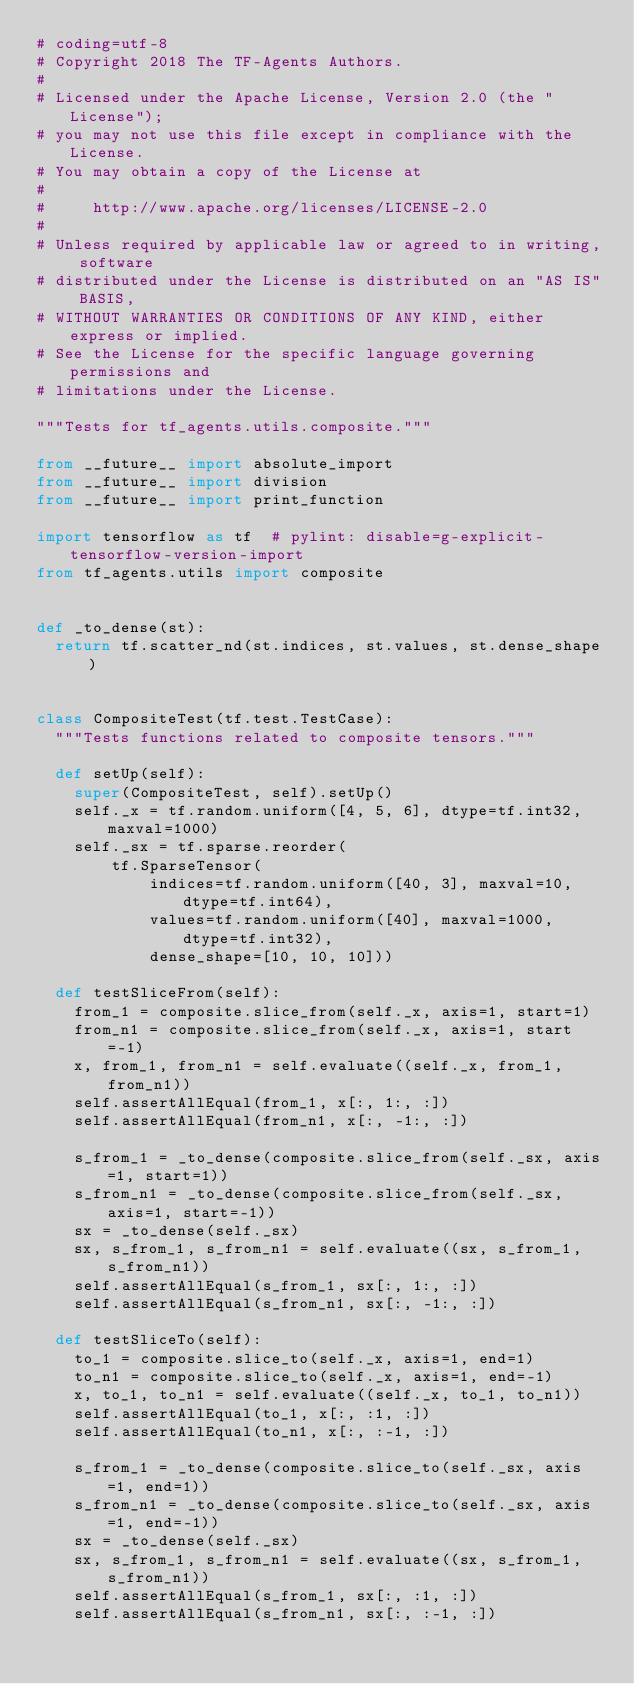<code> <loc_0><loc_0><loc_500><loc_500><_Python_># coding=utf-8
# Copyright 2018 The TF-Agents Authors.
#
# Licensed under the Apache License, Version 2.0 (the "License");
# you may not use this file except in compliance with the License.
# You may obtain a copy of the License at
#
#     http://www.apache.org/licenses/LICENSE-2.0
#
# Unless required by applicable law or agreed to in writing, software
# distributed under the License is distributed on an "AS IS" BASIS,
# WITHOUT WARRANTIES OR CONDITIONS OF ANY KIND, either express or implied.
# See the License for the specific language governing permissions and
# limitations under the License.

"""Tests for tf_agents.utils.composite."""

from __future__ import absolute_import
from __future__ import division
from __future__ import print_function

import tensorflow as tf  # pylint: disable=g-explicit-tensorflow-version-import
from tf_agents.utils import composite


def _to_dense(st):
  return tf.scatter_nd(st.indices, st.values, st.dense_shape)


class CompositeTest(tf.test.TestCase):
  """Tests functions related to composite tensors."""

  def setUp(self):
    super(CompositeTest, self).setUp()
    self._x = tf.random.uniform([4, 5, 6], dtype=tf.int32, maxval=1000)
    self._sx = tf.sparse.reorder(
        tf.SparseTensor(
            indices=tf.random.uniform([40, 3], maxval=10, dtype=tf.int64),
            values=tf.random.uniform([40], maxval=1000, dtype=tf.int32),
            dense_shape=[10, 10, 10]))

  def testSliceFrom(self):
    from_1 = composite.slice_from(self._x, axis=1, start=1)
    from_n1 = composite.slice_from(self._x, axis=1, start=-1)
    x, from_1, from_n1 = self.evaluate((self._x, from_1, from_n1))
    self.assertAllEqual(from_1, x[:, 1:, :])
    self.assertAllEqual(from_n1, x[:, -1:, :])

    s_from_1 = _to_dense(composite.slice_from(self._sx, axis=1, start=1))
    s_from_n1 = _to_dense(composite.slice_from(self._sx, axis=1, start=-1))
    sx = _to_dense(self._sx)
    sx, s_from_1, s_from_n1 = self.evaluate((sx, s_from_1, s_from_n1))
    self.assertAllEqual(s_from_1, sx[:, 1:, :])
    self.assertAllEqual(s_from_n1, sx[:, -1:, :])

  def testSliceTo(self):
    to_1 = composite.slice_to(self._x, axis=1, end=1)
    to_n1 = composite.slice_to(self._x, axis=1, end=-1)
    x, to_1, to_n1 = self.evaluate((self._x, to_1, to_n1))
    self.assertAllEqual(to_1, x[:, :1, :])
    self.assertAllEqual(to_n1, x[:, :-1, :])

    s_from_1 = _to_dense(composite.slice_to(self._sx, axis=1, end=1))
    s_from_n1 = _to_dense(composite.slice_to(self._sx, axis=1, end=-1))
    sx = _to_dense(self._sx)
    sx, s_from_1, s_from_n1 = self.evaluate((sx, s_from_1, s_from_n1))
    self.assertAllEqual(s_from_1, sx[:, :1, :])
    self.assertAllEqual(s_from_n1, sx[:, :-1, :])
</code> 